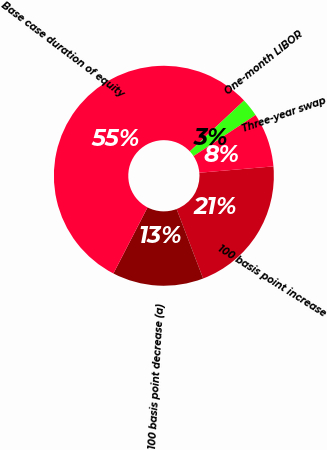Convert chart. <chart><loc_0><loc_0><loc_500><loc_500><pie_chart><fcel>100 basis point increase<fcel>100 basis point decrease (a)<fcel>Base case duration of equity<fcel>One-month LIBOR<fcel>Three-year swap<nl><fcel>20.55%<fcel>13.4%<fcel>55.41%<fcel>2.68%<fcel>7.95%<nl></chart> 